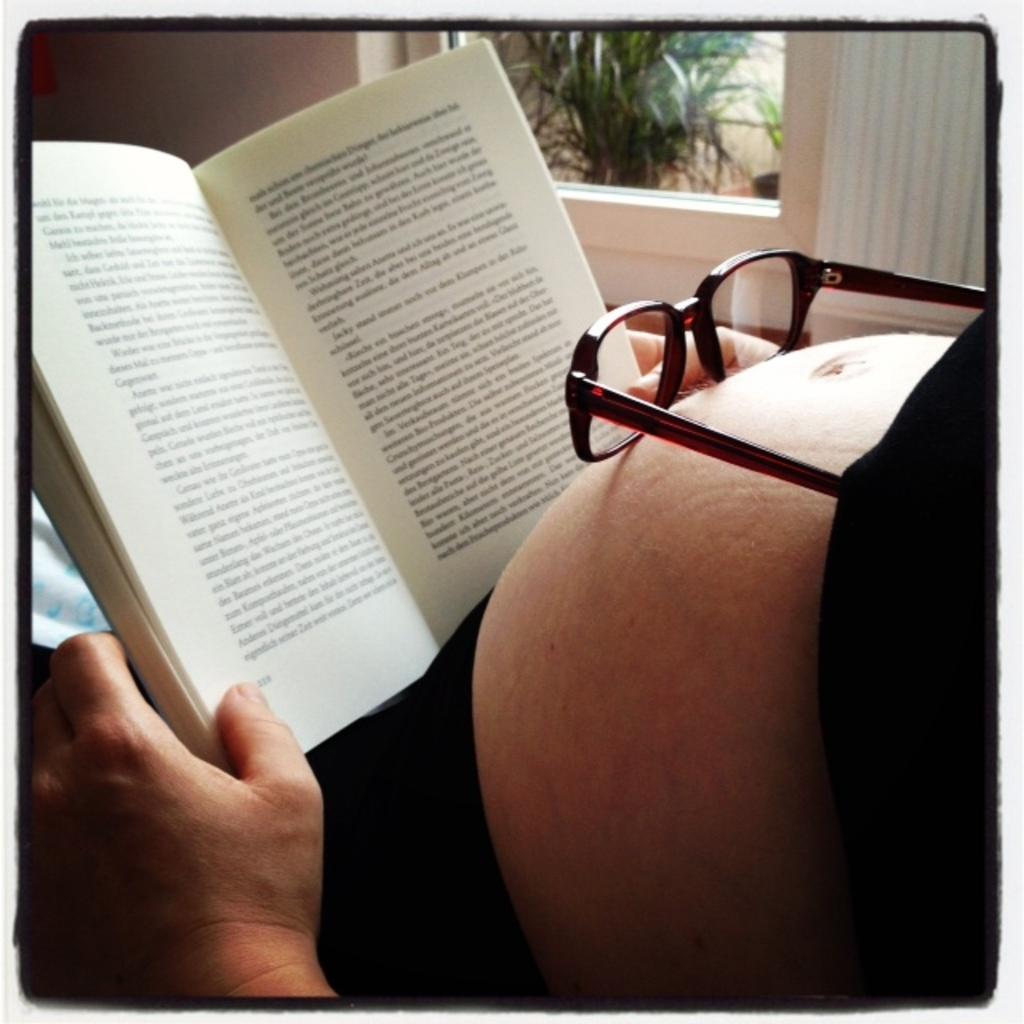Could you give a brief overview of what you see in this image? In this image we can see a book, spectacles, plant, curtain, walls, human hand and human belly. 